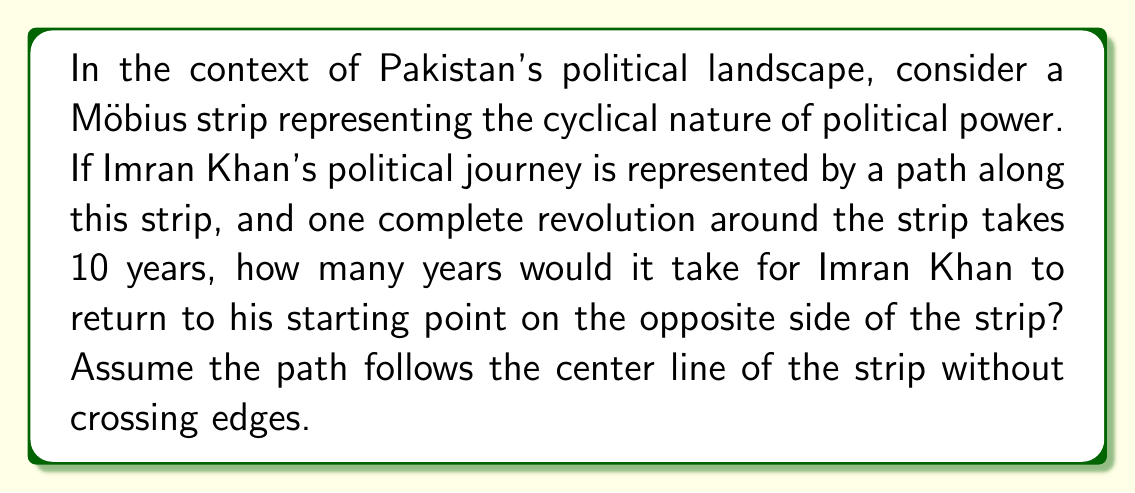Show me your answer to this math problem. To solve this problem, we need to understand the properties of a Möbius strip and how it relates to political cycles:

1) A Möbius strip is a surface with only one side and one boundary component. It can be created by taking a strip of paper, giving it a half-twist, and then joining the ends.

2) In this metaphor, the Möbius strip represents the continuous cycle of political power, where positions can seemingly reverse over time.

3) A key property of the Möbius strip is that if you trace a path along the center of the strip, you will return to the starting point on the opposite side after one complete revolution.

4) Given:
   - One complete revolution takes 10 years
   - We want to return to the starting point on the opposite side

5) To return to the starting point on the opposite side, we need to complete two full revolutions around the Möbius strip. This is because:
   - After one revolution, you end up on the opposite side of where you started
   - After two revolutions, you return to the original starting point

6) Therefore, the time taken can be calculated as:
   $$\text{Time} = 2 \times \text{Time for one revolution}$$
   $$\text{Time} = 2 \times 10 \text{ years} = 20 \text{ years}$$

This result suggests that in this metaphorical representation, it would take 20 years for Imran Khan's political journey to complete a full cycle, returning to a position analogous to his starting point but with potentially reversed circumstances or perspectives.
Answer: 20 years 